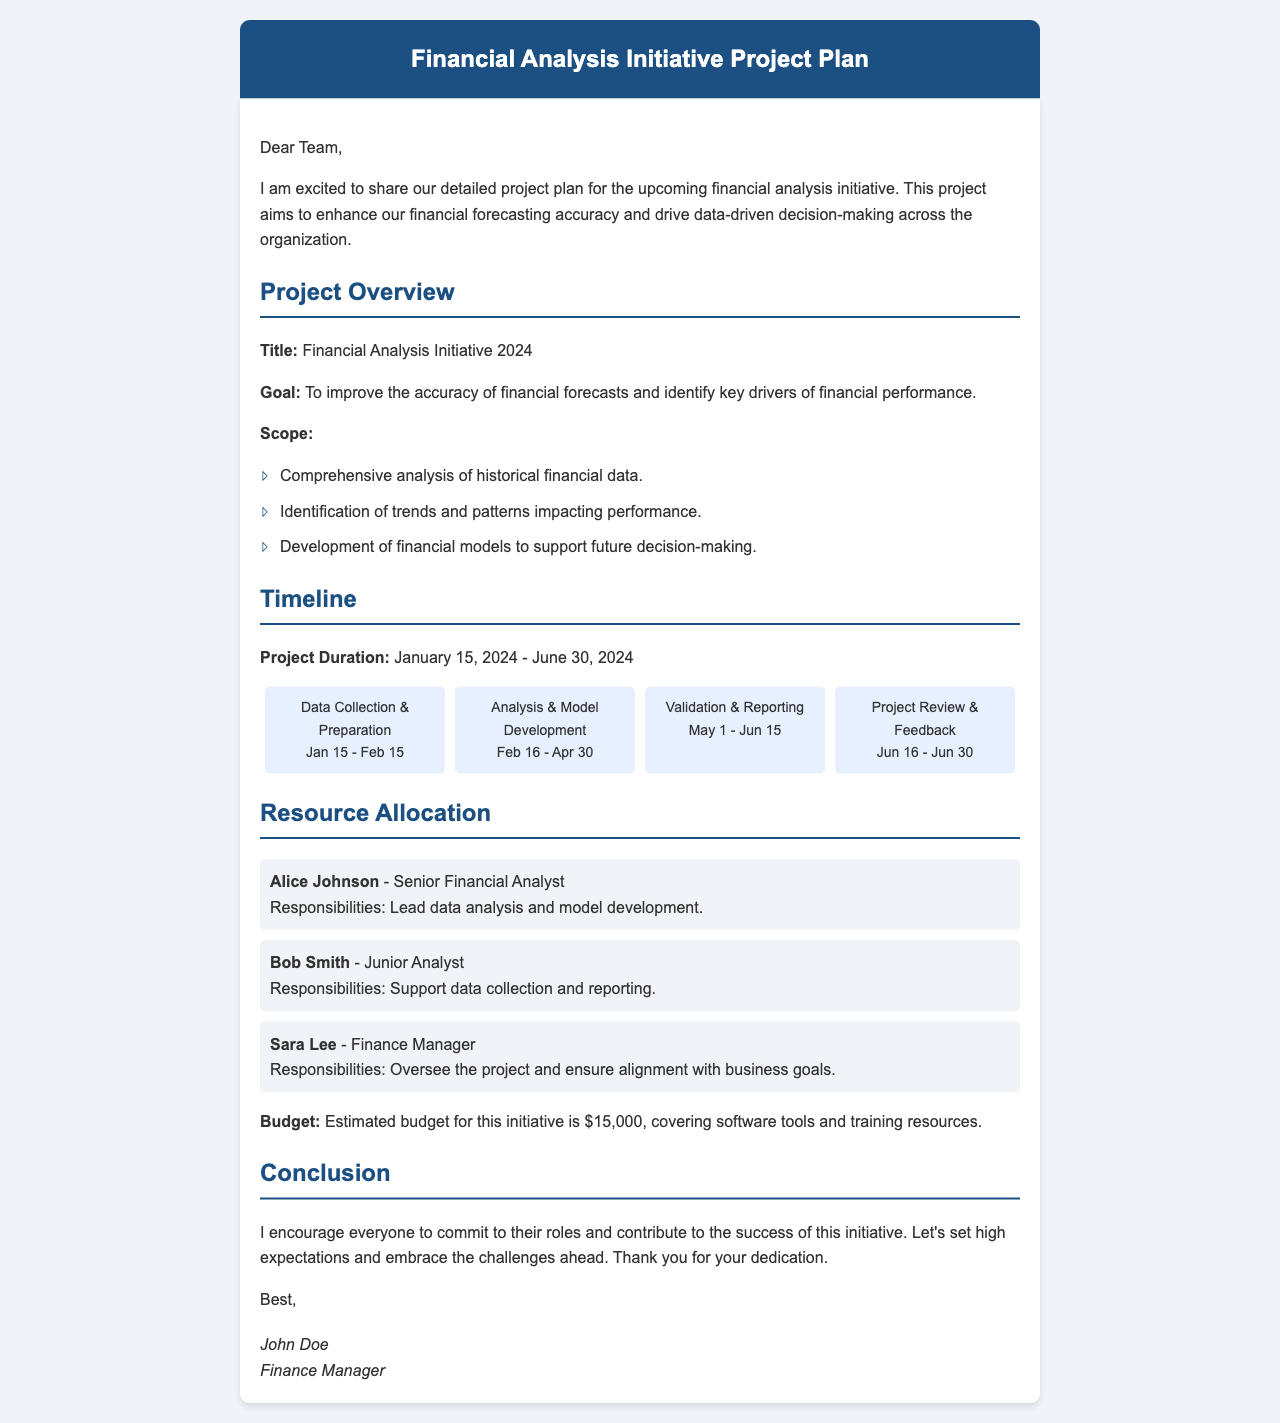what is the title of the project? The title of the project is stated in the project overview section of the document.
Answer: Financial Analysis Initiative 2024 what is the project duration? The project duration is mentioned in the timeline section of the document, specifying the start and end dates.
Answer: January 15, 2024 - June 30, 2024 who is responsible for leading data analysis? The responsibilities for leading data analysis are outlined under resource allocation in the document.
Answer: Alice Johnson what is the estimated budget for the initiative? The estimated budget is provided in the resource allocation section of the document.
Answer: $15,000 during which phase is model development done? The phases are detailed in the timeline section, indicating when model development takes place.
Answer: Feb 16 - Apr 30 what is the goal of the project? The goal is articulated in the project overview section, outlining the aim of the initiative.
Answer: To improve the accuracy of financial forecasts and identify key drivers of financial performance how many phases are there in the project? The number of phases is evident from the timeline section, listing each phase of the project.
Answer: Four who is overseeing the project? The person responsible for overseeing the project is identified in the resource allocation section of the document.
Answer: Sara Lee 